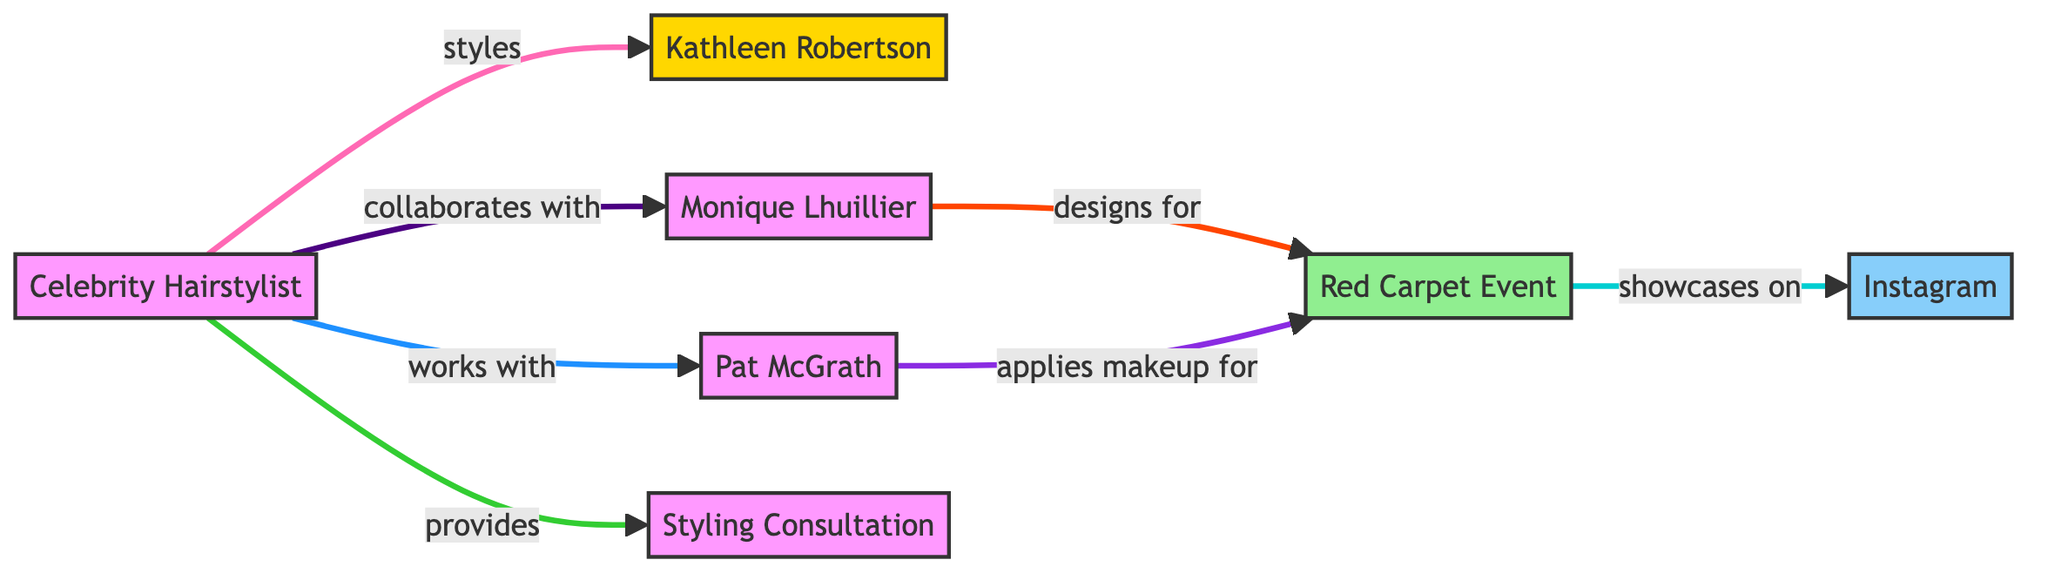What is the total number of nodes in the diagram? The diagram contains six distinct nodes: Celebrity Hairstylist, Kathleen Robertson, Monique Lhuillier, Pat McGrath, Red Carpet Event, and Styling Consultation. Counting these, we find a total of six.
Answer: 6 Who does the Celebrity Hairstylist style? Looking at the directed edge from Celebrity Hairstylist to Kathleen Robertson, we see the label "styles," indicating the specific relationship between them.
Answer: Kathleen Robertson What event does the Fashion Designer design for? There is a directed edge leading from Fashion Designer to Red Carpet Event, marked with "designs for," which clearly shows that this is the event related to the Fashion Designer.
Answer: Red Carpet Event Which platform showcases the Red Carpet Event? The directed edge from Red Carpet Event to Social Media, labeled "showcases on," indicates that this platform is used for showcasing the event.
Answer: Instagram How many edges connect the Celebrity Hairstylist to other nodes? There are four directed edges originating from the Celebrity Hairstylist, connecting to Kathleen Robertson, Fashion Designer, Makeup Artist, and Styling Consultation. Counting these, we see four distinct connections.
Answer: 4 Who collaborates with the Celebrity Hairstylist? The directed edge from Celebrity Hairstylist to Fashion Designer shows the label "collaborates with," indicating that this collaboration exists.
Answer: Monique Lhuillier What is the common subject of the work between the Makeup Artist and the Red Carpet Event? The directed edge from Makeup Artist to Red Carpet Event, labeled "applies makeup for," indicates that the Makeup Artist's work is directly linked to this event.
Answer: Red Carpet Event What role does the Celebrity Hairstylist provide according to the diagram? From the directed edge leading from Celebrity Hairstylist to Styling Consultation, we see the label "provides," indicating that this is the role they fulfill.
Answer: Styling Consultation Which designer is involved in this collaboration network? The node labeled Fashion Designer indicates the type of collaboration taking place in the network, specifically denoting Monique Lhuillier as the designer involved.
Answer: Monique Lhuillier How many direct connections does the Makeup Artist have? The Makeup Artist has one directed edge leading to the Red Carpet Event, as indicated by the "applies makeup for" label, meaning there’s only one connection noted in this diagram.
Answer: 1 